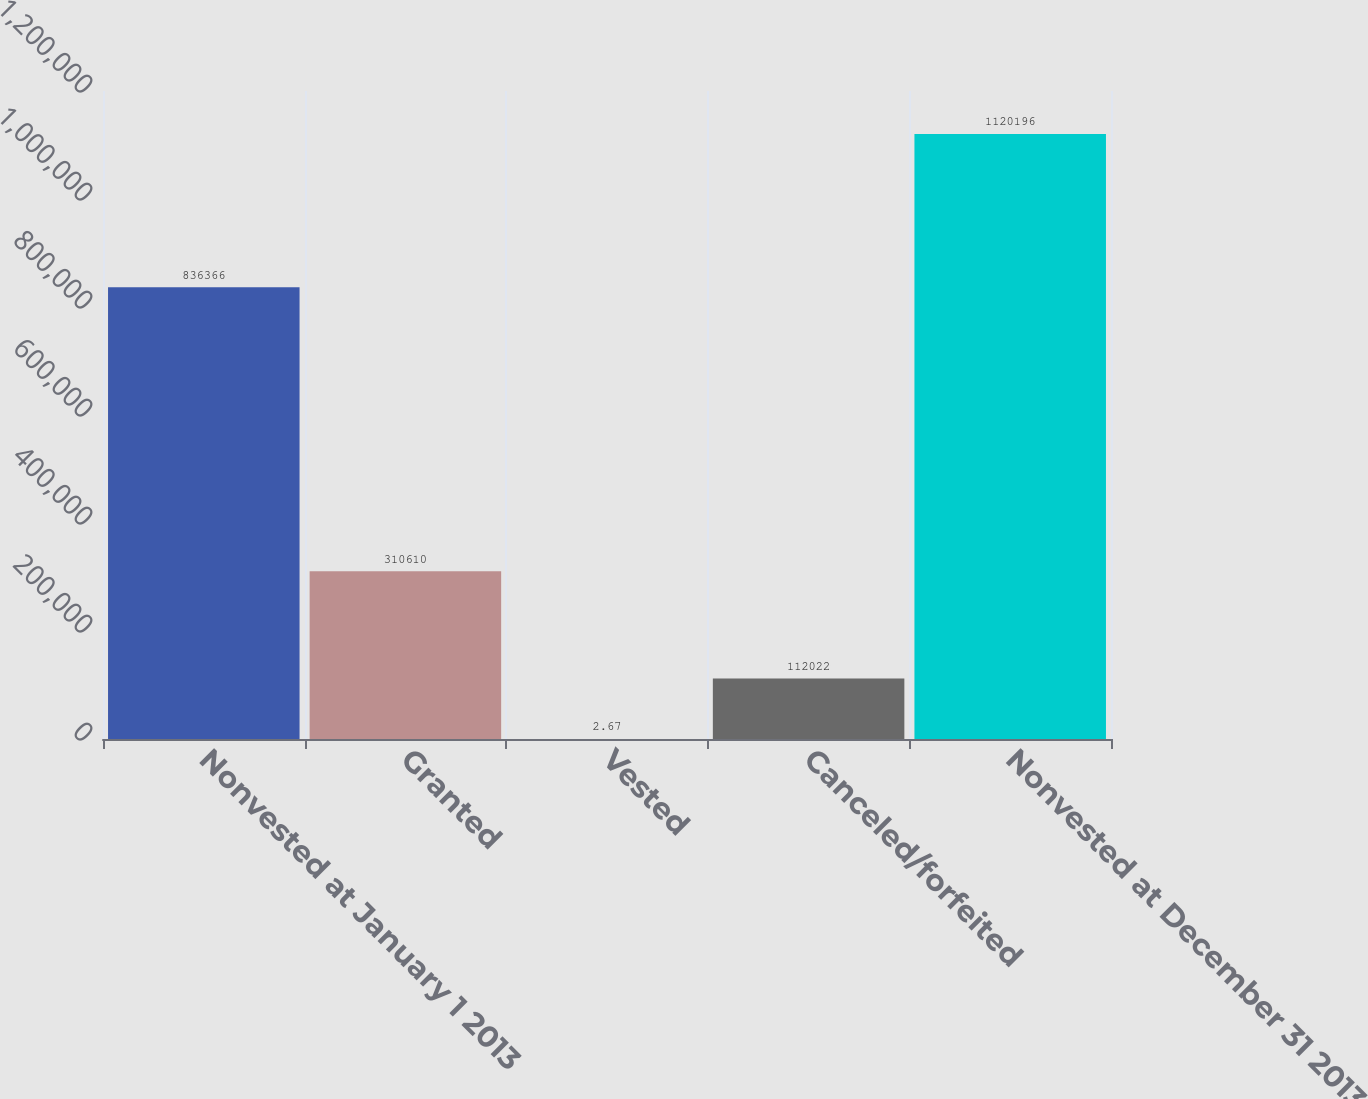Convert chart. <chart><loc_0><loc_0><loc_500><loc_500><bar_chart><fcel>Nonvested at January 1 2013<fcel>Granted<fcel>Vested<fcel>Canceled/forfeited<fcel>Nonvested at December 31 2013<nl><fcel>836366<fcel>310610<fcel>2.67<fcel>112022<fcel>1.1202e+06<nl></chart> 